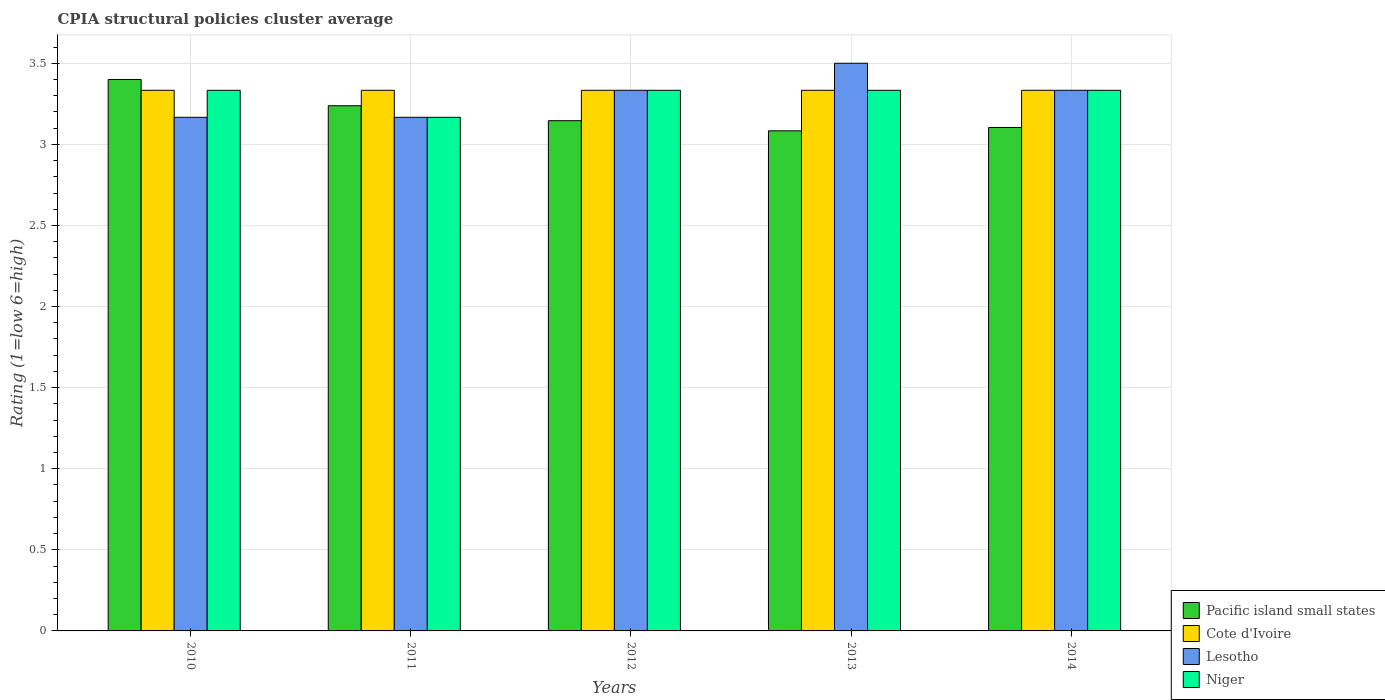How many groups of bars are there?
Offer a terse response. 5. How many bars are there on the 5th tick from the right?
Your answer should be compact. 4. What is the CPIA rating in Lesotho in 2014?
Offer a very short reply. 3.33. Across all years, what is the maximum CPIA rating in Niger?
Give a very brief answer. 3.33. Across all years, what is the minimum CPIA rating in Pacific island small states?
Provide a succinct answer. 3.08. In which year was the CPIA rating in Pacific island small states maximum?
Make the answer very short. 2010. In which year was the CPIA rating in Lesotho minimum?
Your answer should be compact. 2010. What is the total CPIA rating in Cote d'Ivoire in the graph?
Ensure brevity in your answer.  16.67. What is the difference between the CPIA rating in Lesotho in 2012 and that in 2014?
Keep it short and to the point. 3.333333329802457e-6. What is the difference between the CPIA rating in Lesotho in 2010 and the CPIA rating in Niger in 2013?
Offer a terse response. -0.17. What is the average CPIA rating in Lesotho per year?
Your response must be concise. 3.3. In the year 2014, what is the difference between the CPIA rating in Pacific island small states and CPIA rating in Lesotho?
Make the answer very short. -0.23. What is the ratio of the CPIA rating in Cote d'Ivoire in 2010 to that in 2011?
Offer a very short reply. 1. Is the CPIA rating in Niger in 2011 less than that in 2014?
Offer a very short reply. Yes. Is the difference between the CPIA rating in Pacific island small states in 2010 and 2012 greater than the difference between the CPIA rating in Lesotho in 2010 and 2012?
Provide a succinct answer. Yes. What is the difference between the highest and the second highest CPIA rating in Cote d'Ivoire?
Keep it short and to the point. 0. What is the difference between the highest and the lowest CPIA rating in Lesotho?
Give a very brief answer. 0.33. In how many years, is the CPIA rating in Cote d'Ivoire greater than the average CPIA rating in Cote d'Ivoire taken over all years?
Make the answer very short. 4. Is it the case that in every year, the sum of the CPIA rating in Pacific island small states and CPIA rating in Lesotho is greater than the sum of CPIA rating in Niger and CPIA rating in Cote d'Ivoire?
Offer a terse response. No. What does the 4th bar from the left in 2010 represents?
Offer a very short reply. Niger. What does the 4th bar from the right in 2010 represents?
Make the answer very short. Pacific island small states. Is it the case that in every year, the sum of the CPIA rating in Cote d'Ivoire and CPIA rating in Niger is greater than the CPIA rating in Pacific island small states?
Provide a succinct answer. Yes. How many bars are there?
Provide a short and direct response. 20. Are all the bars in the graph horizontal?
Give a very brief answer. No. How many years are there in the graph?
Ensure brevity in your answer.  5. Does the graph contain any zero values?
Provide a succinct answer. No. Does the graph contain grids?
Your answer should be very brief. Yes. How are the legend labels stacked?
Offer a terse response. Vertical. What is the title of the graph?
Provide a succinct answer. CPIA structural policies cluster average. Does "Tonga" appear as one of the legend labels in the graph?
Provide a succinct answer. No. What is the Rating (1=low 6=high) of Pacific island small states in 2010?
Keep it short and to the point. 3.4. What is the Rating (1=low 6=high) in Cote d'Ivoire in 2010?
Keep it short and to the point. 3.33. What is the Rating (1=low 6=high) in Lesotho in 2010?
Offer a very short reply. 3.17. What is the Rating (1=low 6=high) of Niger in 2010?
Your response must be concise. 3.33. What is the Rating (1=low 6=high) in Pacific island small states in 2011?
Make the answer very short. 3.24. What is the Rating (1=low 6=high) in Cote d'Ivoire in 2011?
Offer a terse response. 3.33. What is the Rating (1=low 6=high) of Lesotho in 2011?
Provide a succinct answer. 3.17. What is the Rating (1=low 6=high) of Niger in 2011?
Offer a very short reply. 3.17. What is the Rating (1=low 6=high) in Pacific island small states in 2012?
Offer a terse response. 3.15. What is the Rating (1=low 6=high) of Cote d'Ivoire in 2012?
Your response must be concise. 3.33. What is the Rating (1=low 6=high) in Lesotho in 2012?
Offer a very short reply. 3.33. What is the Rating (1=low 6=high) of Niger in 2012?
Offer a terse response. 3.33. What is the Rating (1=low 6=high) of Pacific island small states in 2013?
Provide a succinct answer. 3.08. What is the Rating (1=low 6=high) of Cote d'Ivoire in 2013?
Ensure brevity in your answer.  3.33. What is the Rating (1=low 6=high) of Lesotho in 2013?
Give a very brief answer. 3.5. What is the Rating (1=low 6=high) in Niger in 2013?
Give a very brief answer. 3.33. What is the Rating (1=low 6=high) in Pacific island small states in 2014?
Your response must be concise. 3.1. What is the Rating (1=low 6=high) of Cote d'Ivoire in 2014?
Provide a short and direct response. 3.33. What is the Rating (1=low 6=high) in Lesotho in 2014?
Offer a very short reply. 3.33. What is the Rating (1=low 6=high) in Niger in 2014?
Offer a very short reply. 3.33. Across all years, what is the maximum Rating (1=low 6=high) in Cote d'Ivoire?
Provide a short and direct response. 3.33. Across all years, what is the maximum Rating (1=low 6=high) of Lesotho?
Provide a short and direct response. 3.5. Across all years, what is the maximum Rating (1=low 6=high) in Niger?
Provide a succinct answer. 3.33. Across all years, what is the minimum Rating (1=low 6=high) of Pacific island small states?
Make the answer very short. 3.08. Across all years, what is the minimum Rating (1=low 6=high) of Cote d'Ivoire?
Offer a terse response. 3.33. Across all years, what is the minimum Rating (1=low 6=high) in Lesotho?
Your answer should be compact. 3.17. Across all years, what is the minimum Rating (1=low 6=high) in Niger?
Your answer should be very brief. 3.17. What is the total Rating (1=low 6=high) of Pacific island small states in the graph?
Your response must be concise. 15.97. What is the total Rating (1=low 6=high) in Cote d'Ivoire in the graph?
Offer a terse response. 16.67. What is the total Rating (1=low 6=high) of Niger in the graph?
Provide a succinct answer. 16.5. What is the difference between the Rating (1=low 6=high) of Pacific island small states in 2010 and that in 2011?
Make the answer very short. 0.16. What is the difference between the Rating (1=low 6=high) of Cote d'Ivoire in 2010 and that in 2011?
Your answer should be very brief. 0. What is the difference between the Rating (1=low 6=high) in Pacific island small states in 2010 and that in 2012?
Your response must be concise. 0.25. What is the difference between the Rating (1=low 6=high) in Lesotho in 2010 and that in 2012?
Provide a succinct answer. -0.17. What is the difference between the Rating (1=low 6=high) in Pacific island small states in 2010 and that in 2013?
Offer a terse response. 0.32. What is the difference between the Rating (1=low 6=high) of Lesotho in 2010 and that in 2013?
Keep it short and to the point. -0.33. What is the difference between the Rating (1=low 6=high) of Pacific island small states in 2010 and that in 2014?
Your response must be concise. 0.3. What is the difference between the Rating (1=low 6=high) in Lesotho in 2010 and that in 2014?
Ensure brevity in your answer.  -0.17. What is the difference between the Rating (1=low 6=high) of Pacific island small states in 2011 and that in 2012?
Make the answer very short. 0.09. What is the difference between the Rating (1=low 6=high) in Cote d'Ivoire in 2011 and that in 2012?
Offer a very short reply. 0. What is the difference between the Rating (1=low 6=high) of Lesotho in 2011 and that in 2012?
Your answer should be compact. -0.17. What is the difference between the Rating (1=low 6=high) of Niger in 2011 and that in 2012?
Offer a very short reply. -0.17. What is the difference between the Rating (1=low 6=high) of Pacific island small states in 2011 and that in 2013?
Ensure brevity in your answer.  0.15. What is the difference between the Rating (1=low 6=high) of Lesotho in 2011 and that in 2013?
Offer a terse response. -0.33. What is the difference between the Rating (1=low 6=high) in Niger in 2011 and that in 2013?
Give a very brief answer. -0.17. What is the difference between the Rating (1=low 6=high) in Pacific island small states in 2011 and that in 2014?
Ensure brevity in your answer.  0.13. What is the difference between the Rating (1=low 6=high) in Cote d'Ivoire in 2011 and that in 2014?
Your answer should be compact. 0. What is the difference between the Rating (1=low 6=high) in Lesotho in 2011 and that in 2014?
Your answer should be compact. -0.17. What is the difference between the Rating (1=low 6=high) of Pacific island small states in 2012 and that in 2013?
Ensure brevity in your answer.  0.06. What is the difference between the Rating (1=low 6=high) of Lesotho in 2012 and that in 2013?
Your response must be concise. -0.17. What is the difference between the Rating (1=low 6=high) of Niger in 2012 and that in 2013?
Your response must be concise. 0. What is the difference between the Rating (1=low 6=high) in Pacific island small states in 2012 and that in 2014?
Provide a short and direct response. 0.04. What is the difference between the Rating (1=low 6=high) in Lesotho in 2012 and that in 2014?
Keep it short and to the point. 0. What is the difference between the Rating (1=low 6=high) of Pacific island small states in 2013 and that in 2014?
Your answer should be very brief. -0.02. What is the difference between the Rating (1=low 6=high) of Niger in 2013 and that in 2014?
Make the answer very short. 0. What is the difference between the Rating (1=low 6=high) of Pacific island small states in 2010 and the Rating (1=low 6=high) of Cote d'Ivoire in 2011?
Make the answer very short. 0.07. What is the difference between the Rating (1=low 6=high) in Pacific island small states in 2010 and the Rating (1=low 6=high) in Lesotho in 2011?
Your response must be concise. 0.23. What is the difference between the Rating (1=low 6=high) in Pacific island small states in 2010 and the Rating (1=low 6=high) in Niger in 2011?
Your response must be concise. 0.23. What is the difference between the Rating (1=low 6=high) in Cote d'Ivoire in 2010 and the Rating (1=low 6=high) in Lesotho in 2011?
Provide a succinct answer. 0.17. What is the difference between the Rating (1=low 6=high) in Pacific island small states in 2010 and the Rating (1=low 6=high) in Cote d'Ivoire in 2012?
Offer a very short reply. 0.07. What is the difference between the Rating (1=low 6=high) of Pacific island small states in 2010 and the Rating (1=low 6=high) of Lesotho in 2012?
Your response must be concise. 0.07. What is the difference between the Rating (1=low 6=high) of Pacific island small states in 2010 and the Rating (1=low 6=high) of Niger in 2012?
Offer a very short reply. 0.07. What is the difference between the Rating (1=low 6=high) in Cote d'Ivoire in 2010 and the Rating (1=low 6=high) in Lesotho in 2012?
Your response must be concise. 0. What is the difference between the Rating (1=low 6=high) in Lesotho in 2010 and the Rating (1=low 6=high) in Niger in 2012?
Offer a very short reply. -0.17. What is the difference between the Rating (1=low 6=high) in Pacific island small states in 2010 and the Rating (1=low 6=high) in Cote d'Ivoire in 2013?
Keep it short and to the point. 0.07. What is the difference between the Rating (1=low 6=high) in Pacific island small states in 2010 and the Rating (1=low 6=high) in Niger in 2013?
Your answer should be very brief. 0.07. What is the difference between the Rating (1=low 6=high) of Cote d'Ivoire in 2010 and the Rating (1=low 6=high) of Lesotho in 2013?
Offer a terse response. -0.17. What is the difference between the Rating (1=low 6=high) in Cote d'Ivoire in 2010 and the Rating (1=low 6=high) in Niger in 2013?
Provide a short and direct response. 0. What is the difference between the Rating (1=low 6=high) of Pacific island small states in 2010 and the Rating (1=low 6=high) of Cote d'Ivoire in 2014?
Your answer should be compact. 0.07. What is the difference between the Rating (1=low 6=high) of Pacific island small states in 2010 and the Rating (1=low 6=high) of Lesotho in 2014?
Your answer should be very brief. 0.07. What is the difference between the Rating (1=low 6=high) of Pacific island small states in 2010 and the Rating (1=low 6=high) of Niger in 2014?
Provide a succinct answer. 0.07. What is the difference between the Rating (1=low 6=high) of Cote d'Ivoire in 2010 and the Rating (1=low 6=high) of Niger in 2014?
Offer a terse response. 0. What is the difference between the Rating (1=low 6=high) in Lesotho in 2010 and the Rating (1=low 6=high) in Niger in 2014?
Your answer should be very brief. -0.17. What is the difference between the Rating (1=low 6=high) in Pacific island small states in 2011 and the Rating (1=low 6=high) in Cote d'Ivoire in 2012?
Offer a very short reply. -0.1. What is the difference between the Rating (1=low 6=high) in Pacific island small states in 2011 and the Rating (1=low 6=high) in Lesotho in 2012?
Make the answer very short. -0.1. What is the difference between the Rating (1=low 6=high) in Pacific island small states in 2011 and the Rating (1=low 6=high) in Niger in 2012?
Keep it short and to the point. -0.1. What is the difference between the Rating (1=low 6=high) in Lesotho in 2011 and the Rating (1=low 6=high) in Niger in 2012?
Your answer should be very brief. -0.17. What is the difference between the Rating (1=low 6=high) in Pacific island small states in 2011 and the Rating (1=low 6=high) in Cote d'Ivoire in 2013?
Your answer should be compact. -0.1. What is the difference between the Rating (1=low 6=high) of Pacific island small states in 2011 and the Rating (1=low 6=high) of Lesotho in 2013?
Provide a short and direct response. -0.26. What is the difference between the Rating (1=low 6=high) of Pacific island small states in 2011 and the Rating (1=low 6=high) of Niger in 2013?
Provide a short and direct response. -0.1. What is the difference between the Rating (1=low 6=high) of Cote d'Ivoire in 2011 and the Rating (1=low 6=high) of Lesotho in 2013?
Make the answer very short. -0.17. What is the difference between the Rating (1=low 6=high) in Cote d'Ivoire in 2011 and the Rating (1=low 6=high) in Niger in 2013?
Your answer should be very brief. 0. What is the difference between the Rating (1=low 6=high) of Lesotho in 2011 and the Rating (1=low 6=high) of Niger in 2013?
Your answer should be compact. -0.17. What is the difference between the Rating (1=low 6=high) of Pacific island small states in 2011 and the Rating (1=low 6=high) of Cote d'Ivoire in 2014?
Your answer should be compact. -0.1. What is the difference between the Rating (1=low 6=high) of Pacific island small states in 2011 and the Rating (1=low 6=high) of Lesotho in 2014?
Ensure brevity in your answer.  -0.1. What is the difference between the Rating (1=low 6=high) in Pacific island small states in 2011 and the Rating (1=low 6=high) in Niger in 2014?
Give a very brief answer. -0.1. What is the difference between the Rating (1=low 6=high) in Cote d'Ivoire in 2011 and the Rating (1=low 6=high) in Lesotho in 2014?
Your answer should be compact. 0. What is the difference between the Rating (1=low 6=high) in Lesotho in 2011 and the Rating (1=low 6=high) in Niger in 2014?
Make the answer very short. -0.17. What is the difference between the Rating (1=low 6=high) of Pacific island small states in 2012 and the Rating (1=low 6=high) of Cote d'Ivoire in 2013?
Keep it short and to the point. -0.19. What is the difference between the Rating (1=low 6=high) in Pacific island small states in 2012 and the Rating (1=low 6=high) in Lesotho in 2013?
Make the answer very short. -0.35. What is the difference between the Rating (1=low 6=high) of Pacific island small states in 2012 and the Rating (1=low 6=high) of Niger in 2013?
Keep it short and to the point. -0.19. What is the difference between the Rating (1=low 6=high) in Cote d'Ivoire in 2012 and the Rating (1=low 6=high) in Niger in 2013?
Your response must be concise. 0. What is the difference between the Rating (1=low 6=high) in Lesotho in 2012 and the Rating (1=low 6=high) in Niger in 2013?
Your response must be concise. 0. What is the difference between the Rating (1=low 6=high) in Pacific island small states in 2012 and the Rating (1=low 6=high) in Cote d'Ivoire in 2014?
Make the answer very short. -0.19. What is the difference between the Rating (1=low 6=high) in Pacific island small states in 2012 and the Rating (1=low 6=high) in Lesotho in 2014?
Offer a terse response. -0.19. What is the difference between the Rating (1=low 6=high) of Pacific island small states in 2012 and the Rating (1=low 6=high) of Niger in 2014?
Offer a very short reply. -0.19. What is the difference between the Rating (1=low 6=high) of Cote d'Ivoire in 2012 and the Rating (1=low 6=high) of Lesotho in 2014?
Make the answer very short. 0. What is the difference between the Rating (1=low 6=high) of Lesotho in 2012 and the Rating (1=low 6=high) of Niger in 2014?
Your answer should be compact. 0. What is the difference between the Rating (1=low 6=high) in Pacific island small states in 2013 and the Rating (1=low 6=high) in Cote d'Ivoire in 2014?
Give a very brief answer. -0.25. What is the difference between the Rating (1=low 6=high) in Pacific island small states in 2013 and the Rating (1=low 6=high) in Lesotho in 2014?
Keep it short and to the point. -0.25. What is the difference between the Rating (1=low 6=high) in Pacific island small states in 2013 and the Rating (1=low 6=high) in Niger in 2014?
Provide a short and direct response. -0.25. What is the difference between the Rating (1=low 6=high) in Cote d'Ivoire in 2013 and the Rating (1=low 6=high) in Lesotho in 2014?
Offer a terse response. 0. What is the difference between the Rating (1=low 6=high) of Lesotho in 2013 and the Rating (1=low 6=high) of Niger in 2014?
Your answer should be compact. 0.17. What is the average Rating (1=low 6=high) of Pacific island small states per year?
Offer a very short reply. 3.19. What is the average Rating (1=low 6=high) in Cote d'Ivoire per year?
Ensure brevity in your answer.  3.33. What is the average Rating (1=low 6=high) of Lesotho per year?
Offer a terse response. 3.3. In the year 2010, what is the difference between the Rating (1=low 6=high) in Pacific island small states and Rating (1=low 6=high) in Cote d'Ivoire?
Your answer should be compact. 0.07. In the year 2010, what is the difference between the Rating (1=low 6=high) of Pacific island small states and Rating (1=low 6=high) of Lesotho?
Provide a short and direct response. 0.23. In the year 2010, what is the difference between the Rating (1=low 6=high) in Pacific island small states and Rating (1=low 6=high) in Niger?
Ensure brevity in your answer.  0.07. In the year 2011, what is the difference between the Rating (1=low 6=high) in Pacific island small states and Rating (1=low 6=high) in Cote d'Ivoire?
Your answer should be compact. -0.1. In the year 2011, what is the difference between the Rating (1=low 6=high) in Pacific island small states and Rating (1=low 6=high) in Lesotho?
Provide a succinct answer. 0.07. In the year 2011, what is the difference between the Rating (1=low 6=high) of Pacific island small states and Rating (1=low 6=high) of Niger?
Provide a short and direct response. 0.07. In the year 2011, what is the difference between the Rating (1=low 6=high) of Cote d'Ivoire and Rating (1=low 6=high) of Lesotho?
Offer a terse response. 0.17. In the year 2012, what is the difference between the Rating (1=low 6=high) in Pacific island small states and Rating (1=low 6=high) in Cote d'Ivoire?
Ensure brevity in your answer.  -0.19. In the year 2012, what is the difference between the Rating (1=low 6=high) of Pacific island small states and Rating (1=low 6=high) of Lesotho?
Your response must be concise. -0.19. In the year 2012, what is the difference between the Rating (1=low 6=high) of Pacific island small states and Rating (1=low 6=high) of Niger?
Provide a short and direct response. -0.19. In the year 2012, what is the difference between the Rating (1=low 6=high) of Lesotho and Rating (1=low 6=high) of Niger?
Your answer should be compact. 0. In the year 2013, what is the difference between the Rating (1=low 6=high) of Pacific island small states and Rating (1=low 6=high) of Cote d'Ivoire?
Keep it short and to the point. -0.25. In the year 2013, what is the difference between the Rating (1=low 6=high) in Pacific island small states and Rating (1=low 6=high) in Lesotho?
Your answer should be compact. -0.42. In the year 2013, what is the difference between the Rating (1=low 6=high) of Cote d'Ivoire and Rating (1=low 6=high) of Niger?
Make the answer very short. 0. In the year 2014, what is the difference between the Rating (1=low 6=high) in Pacific island small states and Rating (1=low 6=high) in Cote d'Ivoire?
Make the answer very short. -0.23. In the year 2014, what is the difference between the Rating (1=low 6=high) of Pacific island small states and Rating (1=low 6=high) of Lesotho?
Offer a very short reply. -0.23. In the year 2014, what is the difference between the Rating (1=low 6=high) of Pacific island small states and Rating (1=low 6=high) of Niger?
Your answer should be compact. -0.23. In the year 2014, what is the difference between the Rating (1=low 6=high) in Cote d'Ivoire and Rating (1=low 6=high) in Lesotho?
Ensure brevity in your answer.  0. In the year 2014, what is the difference between the Rating (1=low 6=high) of Lesotho and Rating (1=low 6=high) of Niger?
Offer a terse response. -0. What is the ratio of the Rating (1=low 6=high) of Pacific island small states in 2010 to that in 2011?
Provide a succinct answer. 1.05. What is the ratio of the Rating (1=low 6=high) of Niger in 2010 to that in 2011?
Provide a short and direct response. 1.05. What is the ratio of the Rating (1=low 6=high) of Pacific island small states in 2010 to that in 2012?
Offer a terse response. 1.08. What is the ratio of the Rating (1=low 6=high) of Cote d'Ivoire in 2010 to that in 2012?
Make the answer very short. 1. What is the ratio of the Rating (1=low 6=high) in Lesotho in 2010 to that in 2012?
Your response must be concise. 0.95. What is the ratio of the Rating (1=low 6=high) of Pacific island small states in 2010 to that in 2013?
Give a very brief answer. 1.1. What is the ratio of the Rating (1=low 6=high) in Lesotho in 2010 to that in 2013?
Offer a very short reply. 0.9. What is the ratio of the Rating (1=low 6=high) of Niger in 2010 to that in 2013?
Make the answer very short. 1. What is the ratio of the Rating (1=low 6=high) of Pacific island small states in 2010 to that in 2014?
Your answer should be very brief. 1.1. What is the ratio of the Rating (1=low 6=high) in Lesotho in 2010 to that in 2014?
Keep it short and to the point. 0.95. What is the ratio of the Rating (1=low 6=high) of Niger in 2010 to that in 2014?
Give a very brief answer. 1. What is the ratio of the Rating (1=low 6=high) of Pacific island small states in 2011 to that in 2012?
Ensure brevity in your answer.  1.03. What is the ratio of the Rating (1=low 6=high) in Cote d'Ivoire in 2011 to that in 2012?
Your answer should be very brief. 1. What is the ratio of the Rating (1=low 6=high) of Lesotho in 2011 to that in 2012?
Give a very brief answer. 0.95. What is the ratio of the Rating (1=low 6=high) of Niger in 2011 to that in 2012?
Offer a terse response. 0.95. What is the ratio of the Rating (1=low 6=high) in Pacific island small states in 2011 to that in 2013?
Provide a succinct answer. 1.05. What is the ratio of the Rating (1=low 6=high) of Lesotho in 2011 to that in 2013?
Keep it short and to the point. 0.9. What is the ratio of the Rating (1=low 6=high) in Niger in 2011 to that in 2013?
Offer a terse response. 0.95. What is the ratio of the Rating (1=low 6=high) of Pacific island small states in 2011 to that in 2014?
Your answer should be compact. 1.04. What is the ratio of the Rating (1=low 6=high) of Niger in 2011 to that in 2014?
Provide a short and direct response. 0.95. What is the ratio of the Rating (1=low 6=high) in Pacific island small states in 2012 to that in 2013?
Make the answer very short. 1.02. What is the ratio of the Rating (1=low 6=high) in Pacific island small states in 2012 to that in 2014?
Ensure brevity in your answer.  1.01. What is the ratio of the Rating (1=low 6=high) of Pacific island small states in 2013 to that in 2014?
Keep it short and to the point. 0.99. What is the difference between the highest and the second highest Rating (1=low 6=high) of Pacific island small states?
Make the answer very short. 0.16. What is the difference between the highest and the second highest Rating (1=low 6=high) of Cote d'Ivoire?
Your response must be concise. 0. What is the difference between the highest and the lowest Rating (1=low 6=high) in Pacific island small states?
Give a very brief answer. 0.32. What is the difference between the highest and the lowest Rating (1=low 6=high) in Cote d'Ivoire?
Keep it short and to the point. 0. What is the difference between the highest and the lowest Rating (1=low 6=high) in Niger?
Make the answer very short. 0.17. 